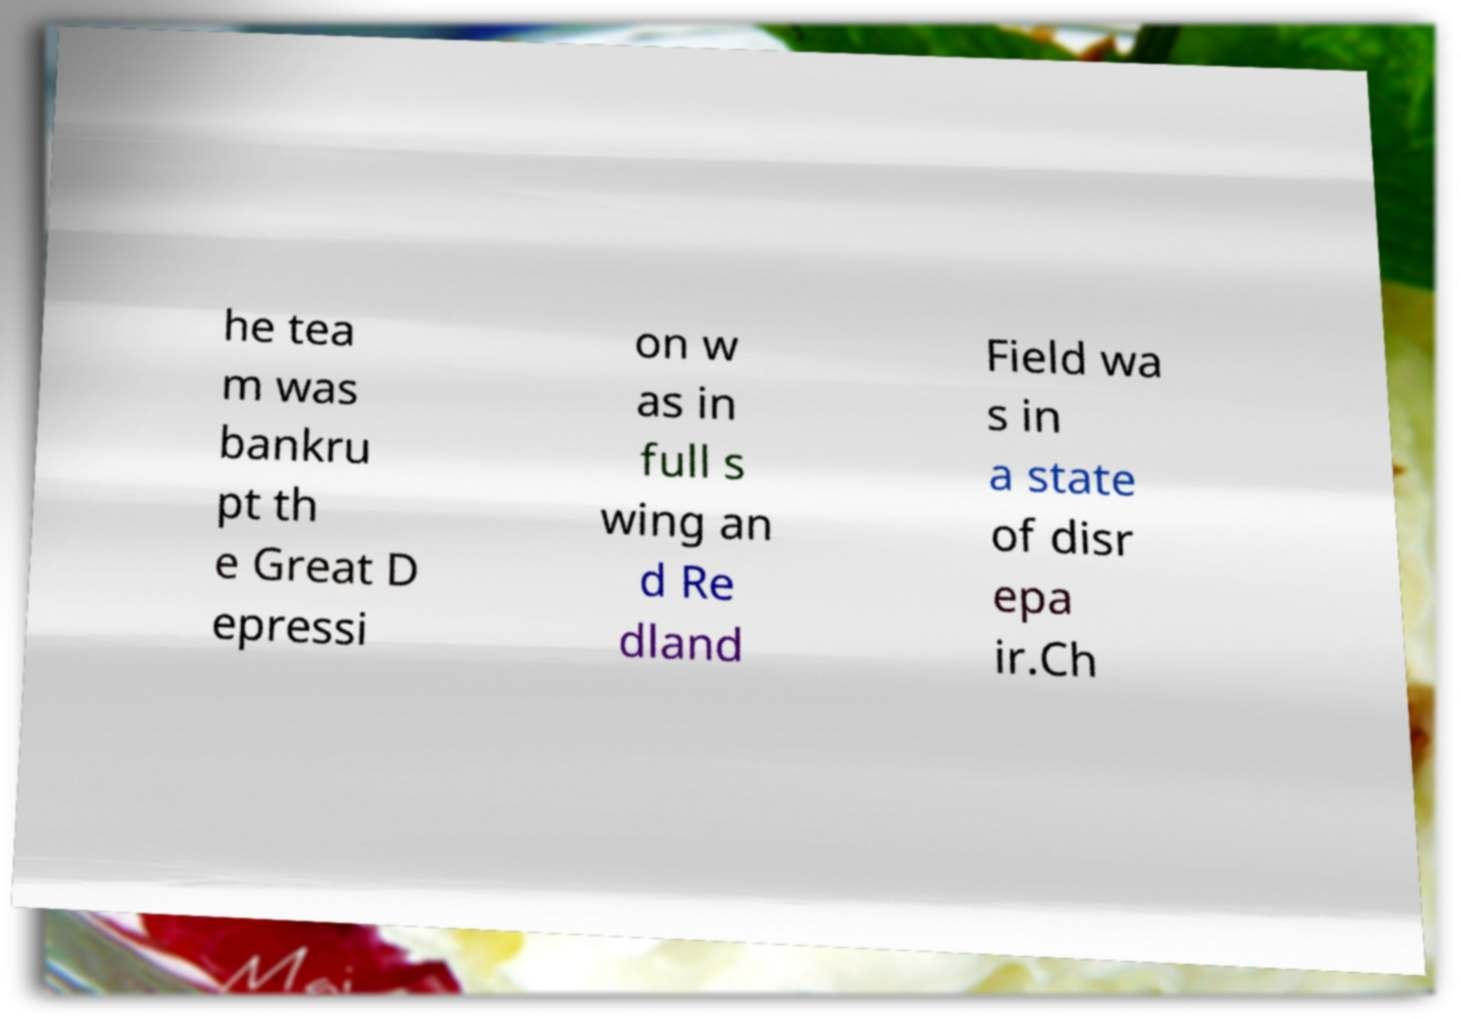Could you extract and type out the text from this image? he tea m was bankru pt th e Great D epressi on w as in full s wing an d Re dland Field wa s in a state of disr epa ir.Ch 